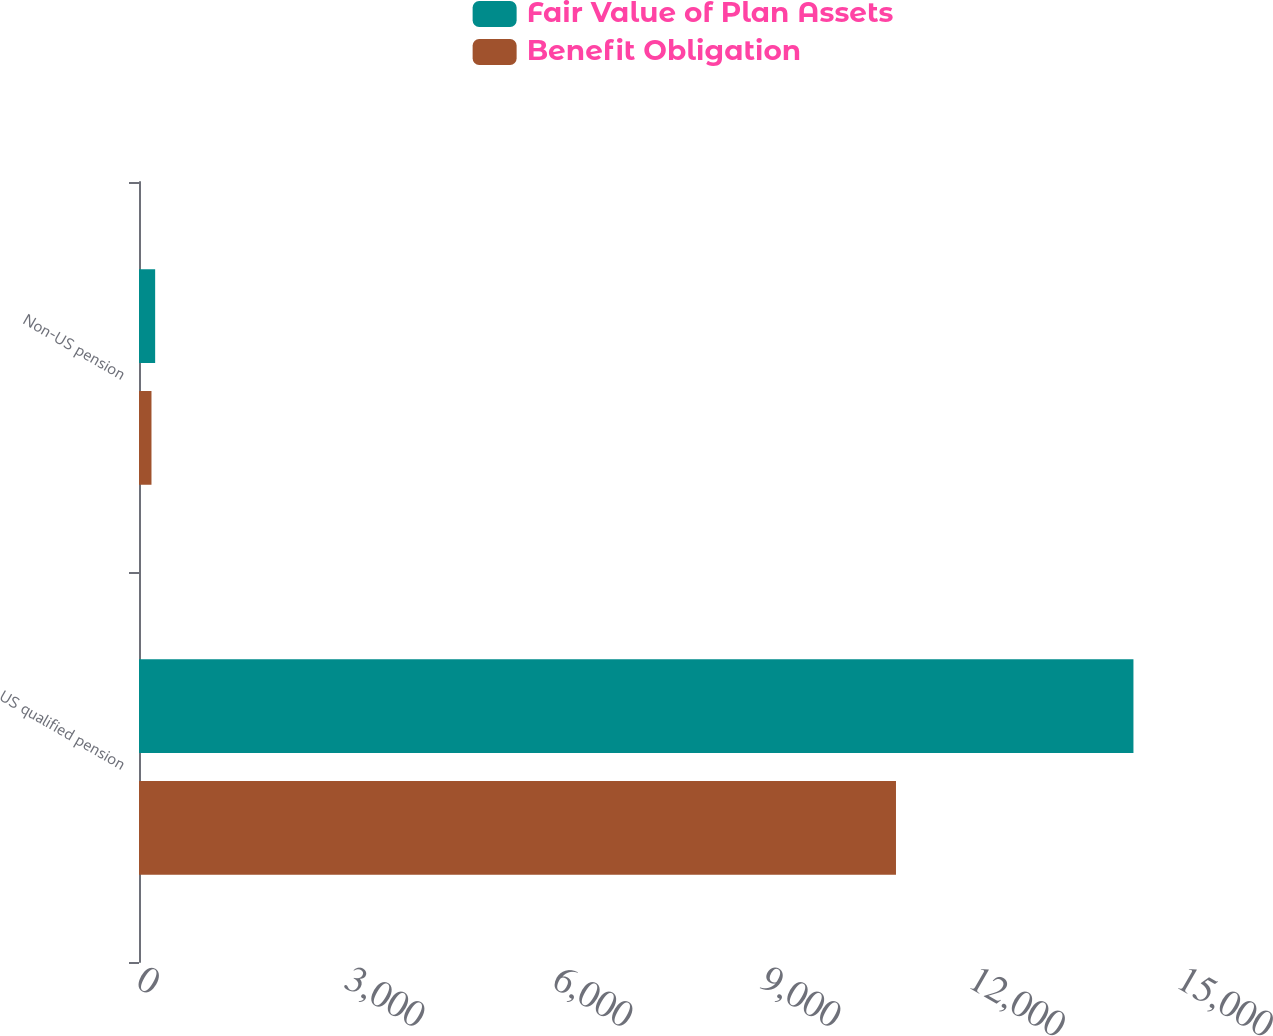Convert chart. <chart><loc_0><loc_0><loc_500><loc_500><stacked_bar_chart><ecel><fcel>US qualified pension<fcel>Non-US pension<nl><fcel>Fair Value of Plan Assets<fcel>14343<fcel>233<nl><fcel>Benefit Obligation<fcel>10918<fcel>180<nl></chart> 